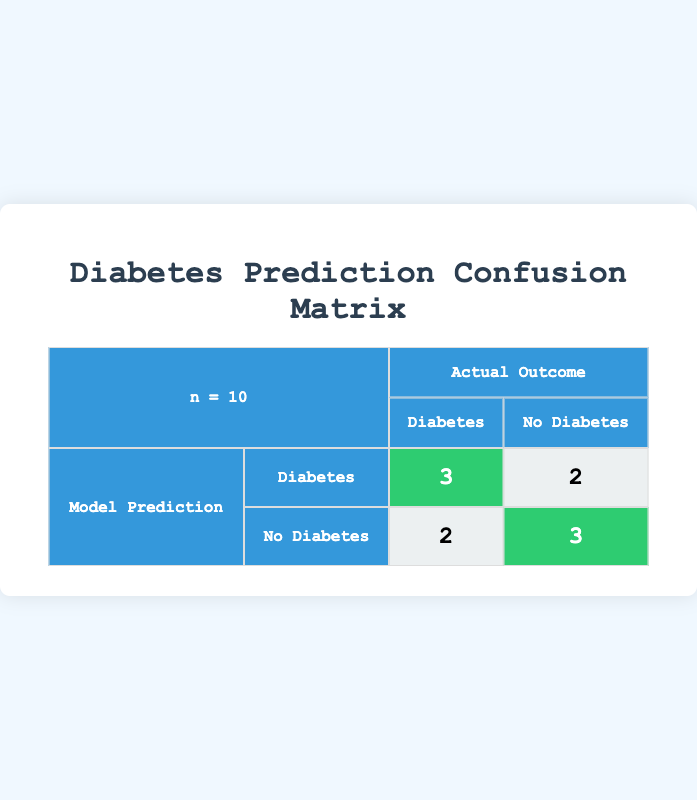What is the value of true positives in the confusion matrix? The confusion matrix shows that the count of true positives (predictions of Diabetes when the actual outcome is also Diabetes) is represented in the first cell of the first row, which has a value of 3.
Answer: 3 What is the count of false negatives in the table? The false negatives (predictions of No Diabetes when the actual outcome is Diabetes) are represented in the second cell of the second row. This value is 2.
Answer: 2 Is the model better at predicting Diabetes or No Diabetes? To determine this, we compare the true positives with false positives for Diabetes (3 vs 2) and true negatives with false negatives for No Diabetes (3 vs 2). The model performs slightly better in predicting Diabetes (more true positives).
Answer: Yes, better at predicting Diabetes What is the total count of actual outcomes for No Diabetes? To find this, we sum the counts of No Diabetes outcomes from both model predictions, which are the second column: 2 (false positives) + 3 (true negatives) = 5.
Answer: 5 What is the sum of all predictions made by the model? The sum of all predictions refers to the total count of the predictions recorded in the table, which is the total of the four cells: 3 (true positives) + 2 (false positives) + 2 (false negatives) + 3 (true negatives) = 10.
Answer: 10 How many times did the model predict No Diabetes correctly? The correct predictions for No Diabetes are represented by true negatives, found in the second cell of the second row of the confusion matrix, which has a value of 3.
Answer: 3 What is the count of false positives in relation to total predictions? The count of false positives is 2. To find the proportion of false positives in relation to total predictions (10), calculate 2 out of 10, which is 0.2 or 20%.
Answer: 20% Is it true that the model has more true negatives than false negatives? Yes, from the confusion matrix, true negatives count is 3 while false negatives count is 2, indicating the model has indeed more true negatives.
Answer: Yes 